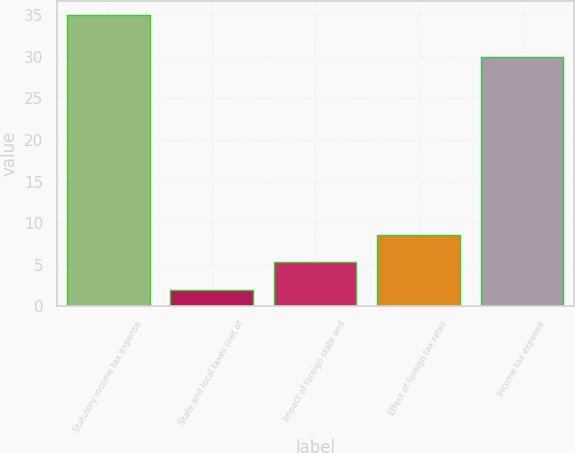Convert chart to OTSL. <chart><loc_0><loc_0><loc_500><loc_500><bar_chart><fcel>Statutory income tax expense<fcel>State and local taxes (net of<fcel>Impact of foreign state and<fcel>Effect of foreign tax rates<fcel>Income tax expense<nl><fcel>35<fcel>2<fcel>5.3<fcel>8.6<fcel>30<nl></chart> 